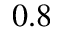<formula> <loc_0><loc_0><loc_500><loc_500>0 . 8</formula> 